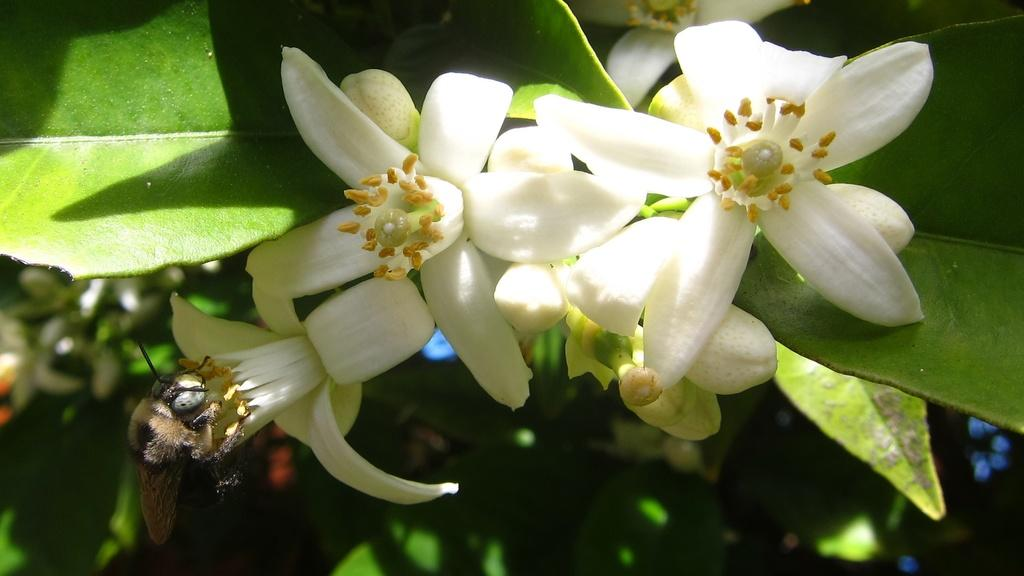What type of flowers can be seen in the image? There are white flowers in the image. Is there any other living organism present in the image? Yes, a honey bee is sitting on the flowers. What can be seen in the background of the image? There are green leaves in the background of the image. What type of bag is being used by the honey bee in the image? There is no bag present in the image, as honey bees do not use bags. 